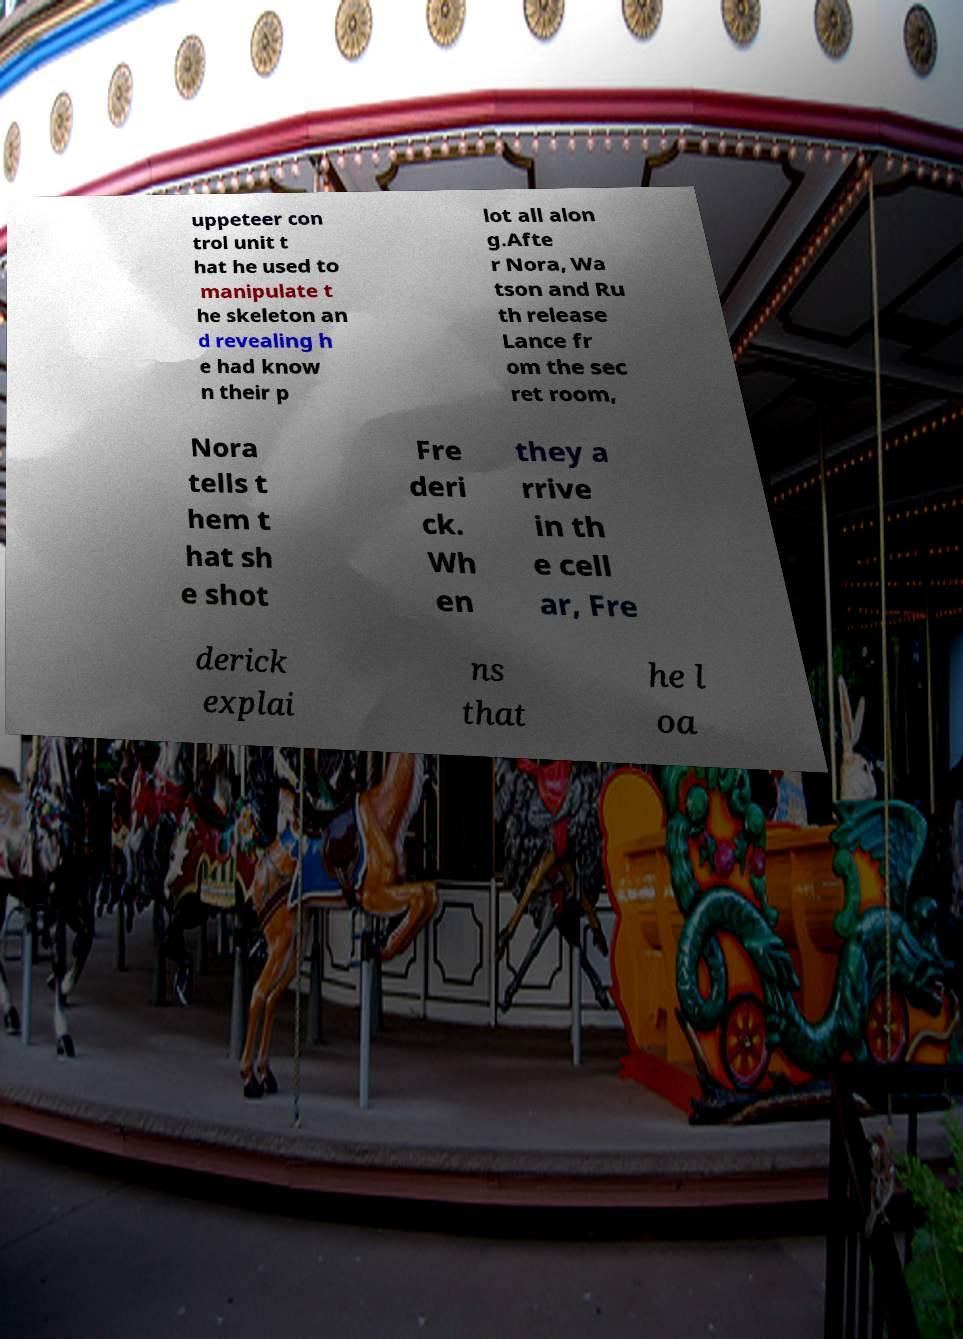Could you assist in decoding the text presented in this image and type it out clearly? uppeteer con trol unit t hat he used to manipulate t he skeleton an d revealing h e had know n their p lot all alon g.Afte r Nora, Wa tson and Ru th release Lance fr om the sec ret room, Nora tells t hem t hat sh e shot Fre deri ck. Wh en they a rrive in th e cell ar, Fre derick explai ns that he l oa 